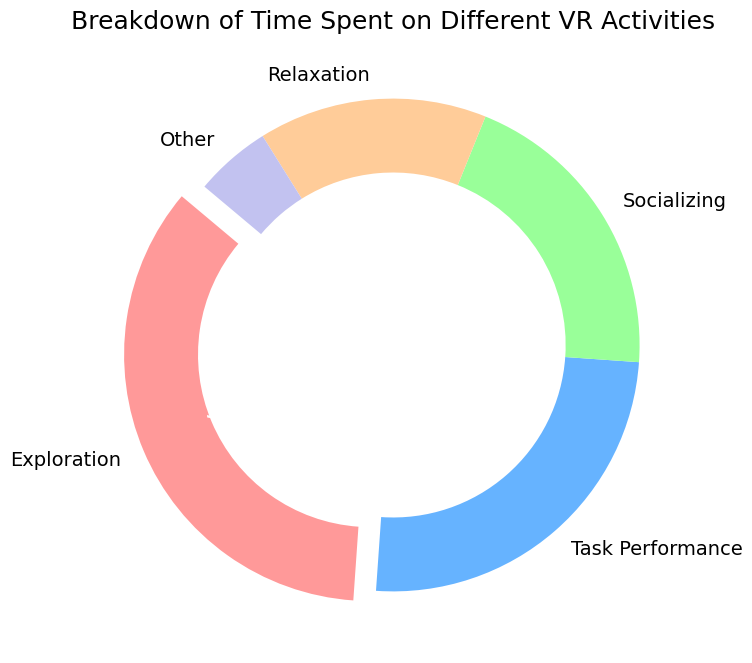What percentage of time is spent on Exploration activities? To answer this, look at the wedge labeled 'Exploration' in the pie chart. The label indicates the percentage of time spent.
Answer: 35% Which activity has the least percentage of time spent? Examine all sections of the pie chart and identify the one with the smallest wedge and percentage label.
Answer: Other How much more time is spent on Exploration compared to Socializing? Find the percentage values for Exploration and Socializing from their respective wedges. Subtract the Socializing percentage from the Exploration percentage: 35% - 20% results in 15%.
Answer: 15% What is the combined percentage of time spent on Task Performance and Relaxation? Add the percentage values for Task Performance (25%) and Relaxation (15%) from their respective wedges: 25% + 15% results in 40%.
Answer: 40% Is more time spent on Socializing or Relaxation? Compare the percentage values of Socializing and Relaxation from their respective wedges. Socializing has 20%, and Relaxation has 15%, so more time is spent on Socializing.
Answer: Socializing What is the difference between the highest and lowest percentages of time spent on activities? Find the highest percentage (Exploration, 35%) and the lowest percentage (Other, 5%) from the wedges. Subtract the lowest from the highest: 35% - 5% results in 30%.
Answer: 30% Which activity segment is highlighted in the pie chart? Identify the wedge that is slightly separated from the rest, indicating it is highlighted. This is the 'Exploration' segment.
Answer: Exploration 